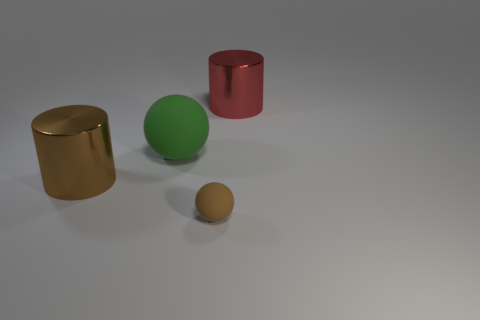Are there any other things that are the same size as the brown ball?
Offer a terse response. No. What is the size of the brown ball?
Provide a short and direct response. Small. Do the metal cylinder to the left of the tiny brown rubber object and the tiny thing have the same color?
Your response must be concise. Yes. There is a sphere in front of the large brown metal thing; is there a red object that is on the left side of it?
Give a very brief answer. No. Is the number of small brown rubber objects that are behind the big brown thing less than the number of small brown matte balls in front of the large red shiny thing?
Your response must be concise. Yes. How big is the metallic thing on the left side of the metallic cylinder that is behind the shiny cylinder in front of the red metal object?
Your answer should be compact. Large. There is a brown thing that is left of the brown rubber thing; does it have the same size as the green matte ball?
Ensure brevity in your answer.  Yes. What number of other objects are there of the same material as the brown cylinder?
Your answer should be compact. 1. Is the number of large yellow rubber blocks greater than the number of green objects?
Your answer should be very brief. No. What material is the brown object right of the big brown metal cylinder in front of the large shiny cylinder that is to the right of the brown cylinder made of?
Ensure brevity in your answer.  Rubber. 